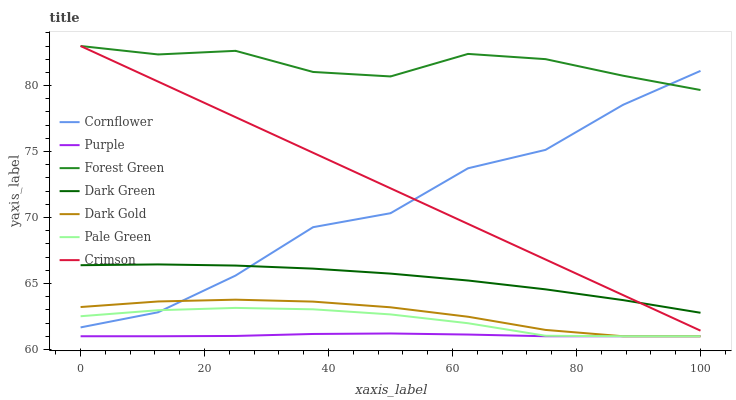Does Purple have the minimum area under the curve?
Answer yes or no. Yes. Does Forest Green have the maximum area under the curve?
Answer yes or no. Yes. Does Dark Gold have the minimum area under the curve?
Answer yes or no. No. Does Dark Gold have the maximum area under the curve?
Answer yes or no. No. Is Crimson the smoothest?
Answer yes or no. Yes. Is Cornflower the roughest?
Answer yes or no. Yes. Is Dark Gold the smoothest?
Answer yes or no. No. Is Dark Gold the roughest?
Answer yes or no. No. Does Dark Gold have the lowest value?
Answer yes or no. Yes. Does Forest Green have the lowest value?
Answer yes or no. No. Does Crimson have the highest value?
Answer yes or no. Yes. Does Dark Gold have the highest value?
Answer yes or no. No. Is Pale Green less than Dark Green?
Answer yes or no. Yes. Is Crimson greater than Pale Green?
Answer yes or no. Yes. Does Crimson intersect Cornflower?
Answer yes or no. Yes. Is Crimson less than Cornflower?
Answer yes or no. No. Is Crimson greater than Cornflower?
Answer yes or no. No. Does Pale Green intersect Dark Green?
Answer yes or no. No. 